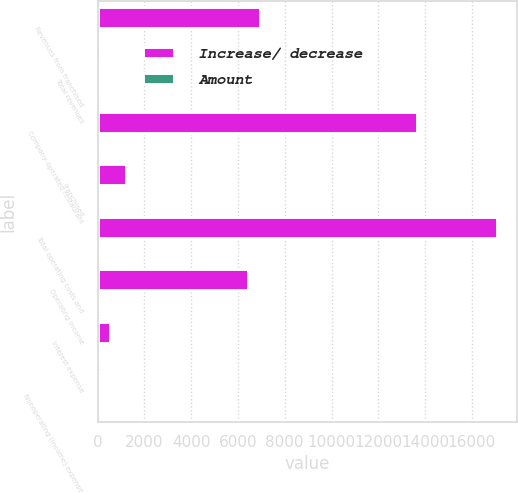<chart> <loc_0><loc_0><loc_500><loc_500><stacked_bar_chart><ecel><fcel>Revenues from franchised<fcel>Total revenues<fcel>Company-operated restaurant<fcel>Franchised<fcel>Total operating costs and<fcel>Operating income<fcel>Interest expense<fcel>Nonoperating (income) expense<nl><fcel>Increase/ decrease<fcel>6961<fcel>66<fcel>13653<fcel>1230<fcel>17079<fcel>6443<fcel>523<fcel>78<nl><fcel>Amount<fcel>13<fcel>3<fcel>1<fcel>8<fcel>10<fcel>66<fcel>27<fcel>25<nl></chart> 